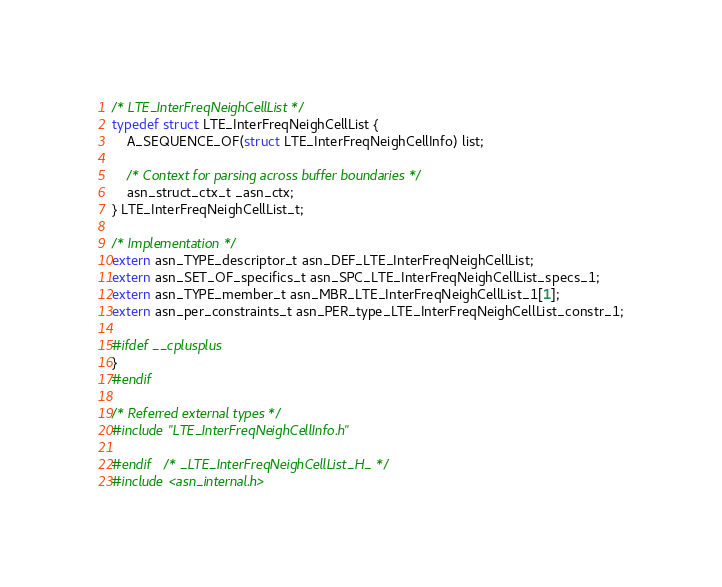<code> <loc_0><loc_0><loc_500><loc_500><_C_>
/* LTE_InterFreqNeighCellList */
typedef struct LTE_InterFreqNeighCellList {
	A_SEQUENCE_OF(struct LTE_InterFreqNeighCellInfo) list;
	
	/* Context for parsing across buffer boundaries */
	asn_struct_ctx_t _asn_ctx;
} LTE_InterFreqNeighCellList_t;

/* Implementation */
extern asn_TYPE_descriptor_t asn_DEF_LTE_InterFreqNeighCellList;
extern asn_SET_OF_specifics_t asn_SPC_LTE_InterFreqNeighCellList_specs_1;
extern asn_TYPE_member_t asn_MBR_LTE_InterFreqNeighCellList_1[1];
extern asn_per_constraints_t asn_PER_type_LTE_InterFreqNeighCellList_constr_1;

#ifdef __cplusplus
}
#endif

/* Referred external types */
#include "LTE_InterFreqNeighCellInfo.h"

#endif	/* _LTE_InterFreqNeighCellList_H_ */
#include <asn_internal.h>
</code> 